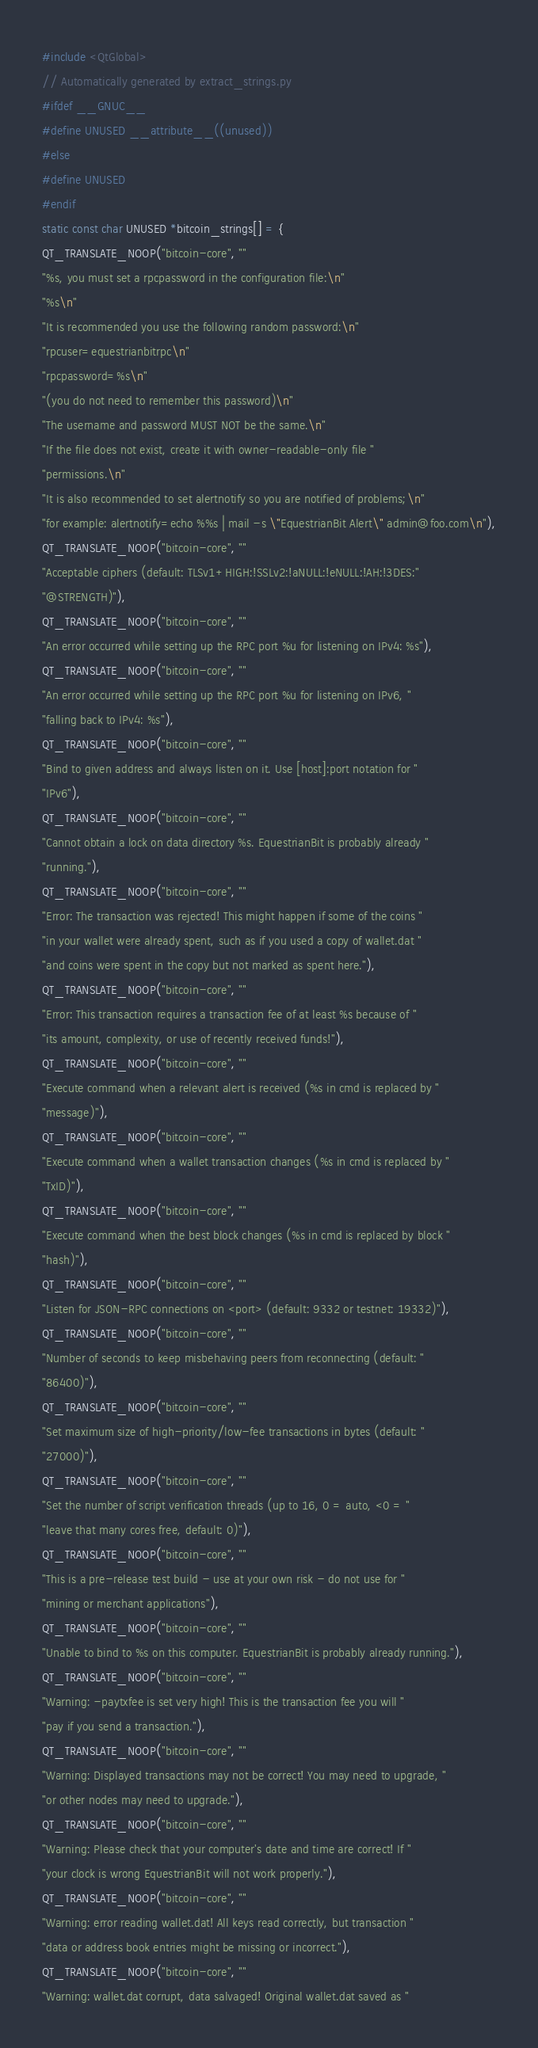<code> <loc_0><loc_0><loc_500><loc_500><_C++_>#include <QtGlobal>
// Automatically generated by extract_strings.py
#ifdef __GNUC__
#define UNUSED __attribute__((unused))
#else
#define UNUSED
#endif
static const char UNUSED *bitcoin_strings[] = {
QT_TRANSLATE_NOOP("bitcoin-core", ""
"%s, you must set a rpcpassword in the configuration file:\n"
"%s\n"
"It is recommended you use the following random password:\n"
"rpcuser=equestrianbitrpc\n"
"rpcpassword=%s\n"
"(you do not need to remember this password)\n"
"The username and password MUST NOT be the same.\n"
"If the file does not exist, create it with owner-readable-only file "
"permissions.\n"
"It is also recommended to set alertnotify so you are notified of problems;\n"
"for example: alertnotify=echo %%s | mail -s \"EquestrianBit Alert\" admin@foo.com\n"),
QT_TRANSLATE_NOOP("bitcoin-core", ""
"Acceptable ciphers (default: TLSv1+HIGH:!SSLv2:!aNULL:!eNULL:!AH:!3DES:"
"@STRENGTH)"),
QT_TRANSLATE_NOOP("bitcoin-core", ""
"An error occurred while setting up the RPC port %u for listening on IPv4: %s"),
QT_TRANSLATE_NOOP("bitcoin-core", ""
"An error occurred while setting up the RPC port %u for listening on IPv6, "
"falling back to IPv4: %s"),
QT_TRANSLATE_NOOP("bitcoin-core", ""
"Bind to given address and always listen on it. Use [host]:port notation for "
"IPv6"),
QT_TRANSLATE_NOOP("bitcoin-core", ""
"Cannot obtain a lock on data directory %s. EquestrianBit is probably already "
"running."),
QT_TRANSLATE_NOOP("bitcoin-core", ""
"Error: The transaction was rejected! This might happen if some of the coins "
"in your wallet were already spent, such as if you used a copy of wallet.dat "
"and coins were spent in the copy but not marked as spent here."),
QT_TRANSLATE_NOOP("bitcoin-core", ""
"Error: This transaction requires a transaction fee of at least %s because of "
"its amount, complexity, or use of recently received funds!"),
QT_TRANSLATE_NOOP("bitcoin-core", ""
"Execute command when a relevant alert is received (%s in cmd is replaced by "
"message)"),
QT_TRANSLATE_NOOP("bitcoin-core", ""
"Execute command when a wallet transaction changes (%s in cmd is replaced by "
"TxID)"),
QT_TRANSLATE_NOOP("bitcoin-core", ""
"Execute command when the best block changes (%s in cmd is replaced by block "
"hash)"),
QT_TRANSLATE_NOOP("bitcoin-core", ""
"Listen for JSON-RPC connections on <port> (default: 9332 or testnet: 19332)"),
QT_TRANSLATE_NOOP("bitcoin-core", ""
"Number of seconds to keep misbehaving peers from reconnecting (default: "
"86400)"),
QT_TRANSLATE_NOOP("bitcoin-core", ""
"Set maximum size of high-priority/low-fee transactions in bytes (default: "
"27000)"),
QT_TRANSLATE_NOOP("bitcoin-core", ""
"Set the number of script verification threads (up to 16, 0 = auto, <0 = "
"leave that many cores free, default: 0)"),
QT_TRANSLATE_NOOP("bitcoin-core", ""
"This is a pre-release test build - use at your own risk - do not use for "
"mining or merchant applications"),
QT_TRANSLATE_NOOP("bitcoin-core", ""
"Unable to bind to %s on this computer. EquestrianBit is probably already running."),
QT_TRANSLATE_NOOP("bitcoin-core", ""
"Warning: -paytxfee is set very high! This is the transaction fee you will "
"pay if you send a transaction."),
QT_TRANSLATE_NOOP("bitcoin-core", ""
"Warning: Displayed transactions may not be correct! You may need to upgrade, "
"or other nodes may need to upgrade."),
QT_TRANSLATE_NOOP("bitcoin-core", ""
"Warning: Please check that your computer's date and time are correct! If "
"your clock is wrong EquestrianBit will not work properly."),
QT_TRANSLATE_NOOP("bitcoin-core", ""
"Warning: error reading wallet.dat! All keys read correctly, but transaction "
"data or address book entries might be missing or incorrect."),
QT_TRANSLATE_NOOP("bitcoin-core", ""
"Warning: wallet.dat corrupt, data salvaged! Original wallet.dat saved as "</code> 